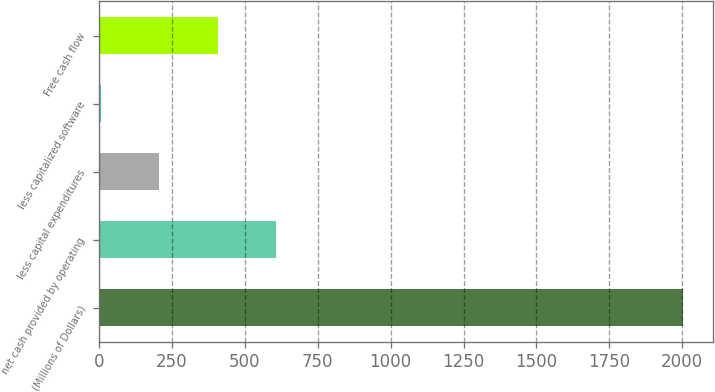Convert chart to OTSL. <chart><loc_0><loc_0><loc_500><loc_500><bar_chart><fcel>(Millions of Dollars)<fcel>net cash provided by operating<fcel>less capital expenditures<fcel>less capitalized software<fcel>Free cash flow<nl><fcel>2004<fcel>606.1<fcel>206.7<fcel>7<fcel>406.4<nl></chart> 